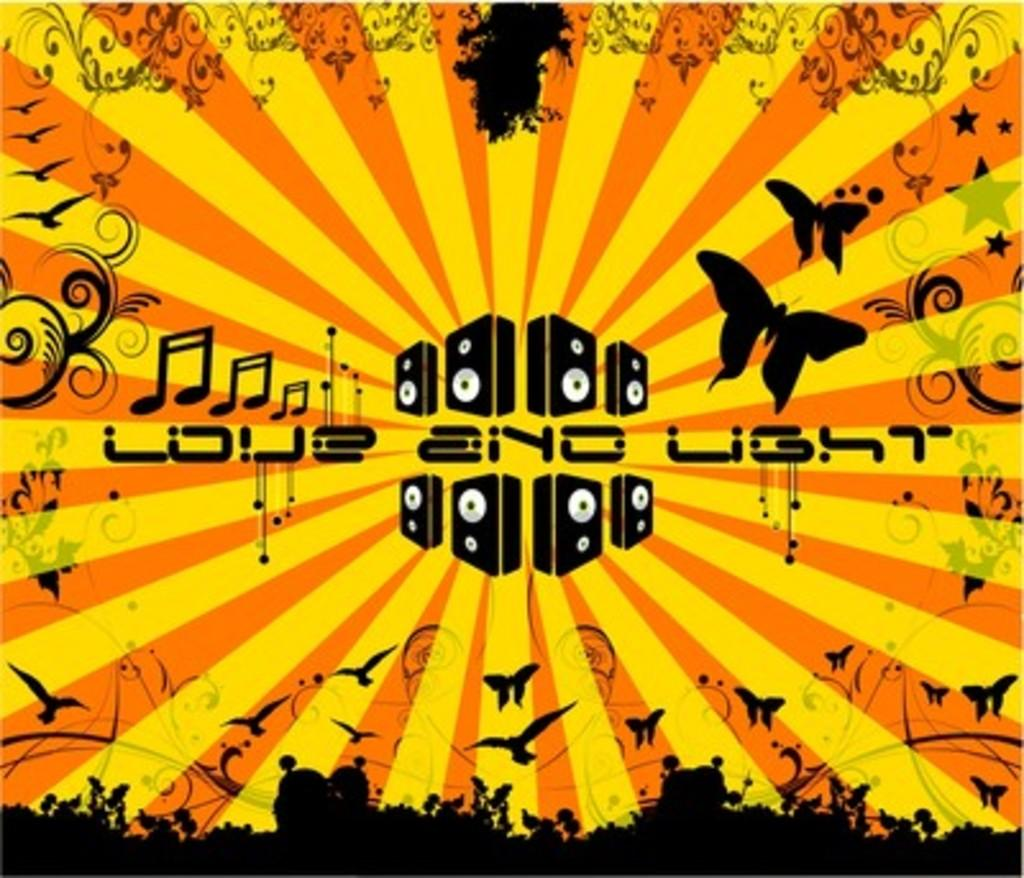<image>
Give a short and clear explanation of the subsequent image. a black, yellow and orange poster that says 'love and light' on it 